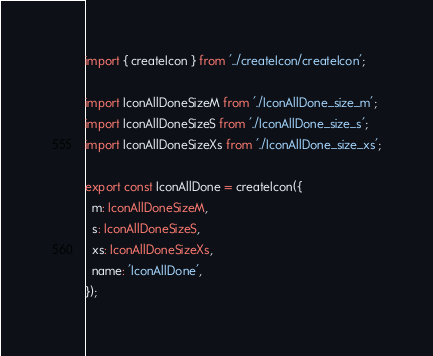<code> <loc_0><loc_0><loc_500><loc_500><_TypeScript_>import { createIcon } from '../createIcon/createIcon';

import IconAllDoneSizeM from './IconAllDone_size_m';
import IconAllDoneSizeS from './IconAllDone_size_s';
import IconAllDoneSizeXs from './IconAllDone_size_xs';

export const IconAllDone = createIcon({
  m: IconAllDoneSizeM,
  s: IconAllDoneSizeS,
  xs: IconAllDoneSizeXs,
  name: 'IconAllDone',
});
</code> 